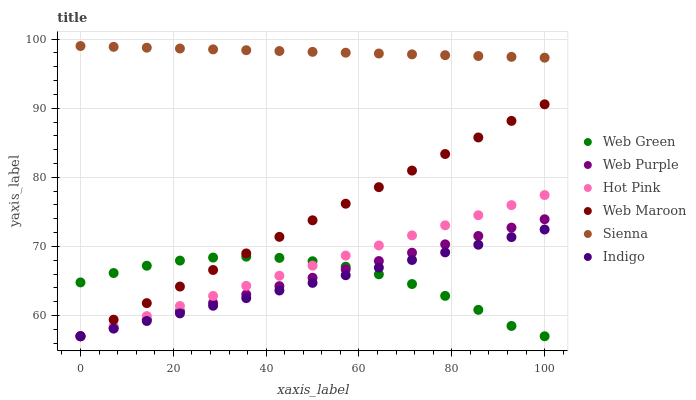Does Indigo have the minimum area under the curve?
Answer yes or no. Yes. Does Sienna have the maximum area under the curve?
Answer yes or no. Yes. Does Hot Pink have the minimum area under the curve?
Answer yes or no. No. Does Hot Pink have the maximum area under the curve?
Answer yes or no. No. Is Indigo the smoothest?
Answer yes or no. Yes. Is Web Green the roughest?
Answer yes or no. Yes. Is Hot Pink the smoothest?
Answer yes or no. No. Is Hot Pink the roughest?
Answer yes or no. No. Does Indigo have the lowest value?
Answer yes or no. Yes. Does Sienna have the lowest value?
Answer yes or no. No. Does Sienna have the highest value?
Answer yes or no. Yes. Does Hot Pink have the highest value?
Answer yes or no. No. Is Web Maroon less than Sienna?
Answer yes or no. Yes. Is Sienna greater than Hot Pink?
Answer yes or no. Yes. Does Web Purple intersect Web Maroon?
Answer yes or no. Yes. Is Web Purple less than Web Maroon?
Answer yes or no. No. Is Web Purple greater than Web Maroon?
Answer yes or no. No. Does Web Maroon intersect Sienna?
Answer yes or no. No. 